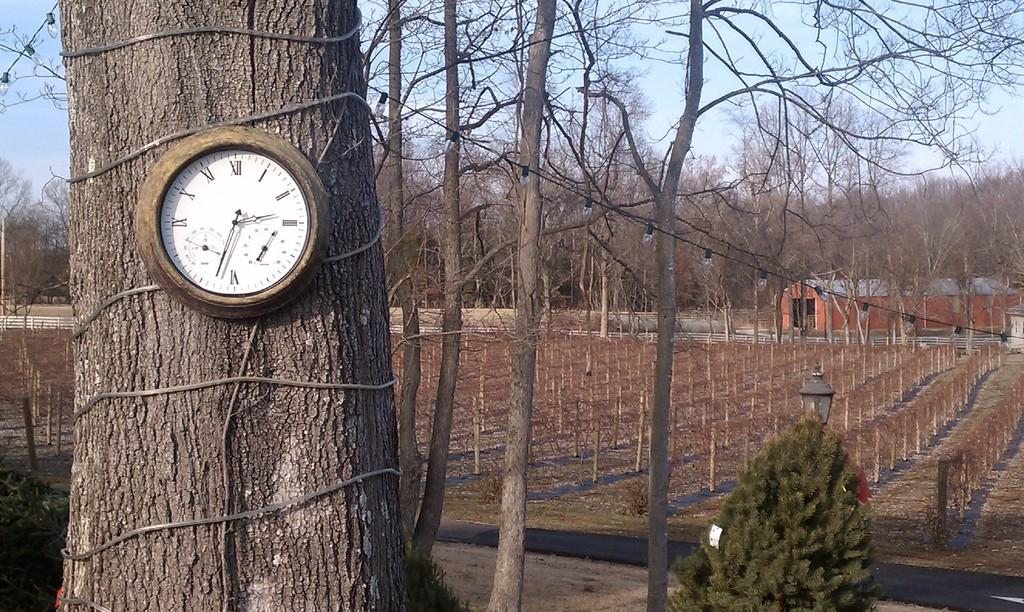Provide a one-sentence caption for the provided image. An analog wall clock mounted on a tree trunk outdoors with Roman Numerals. 